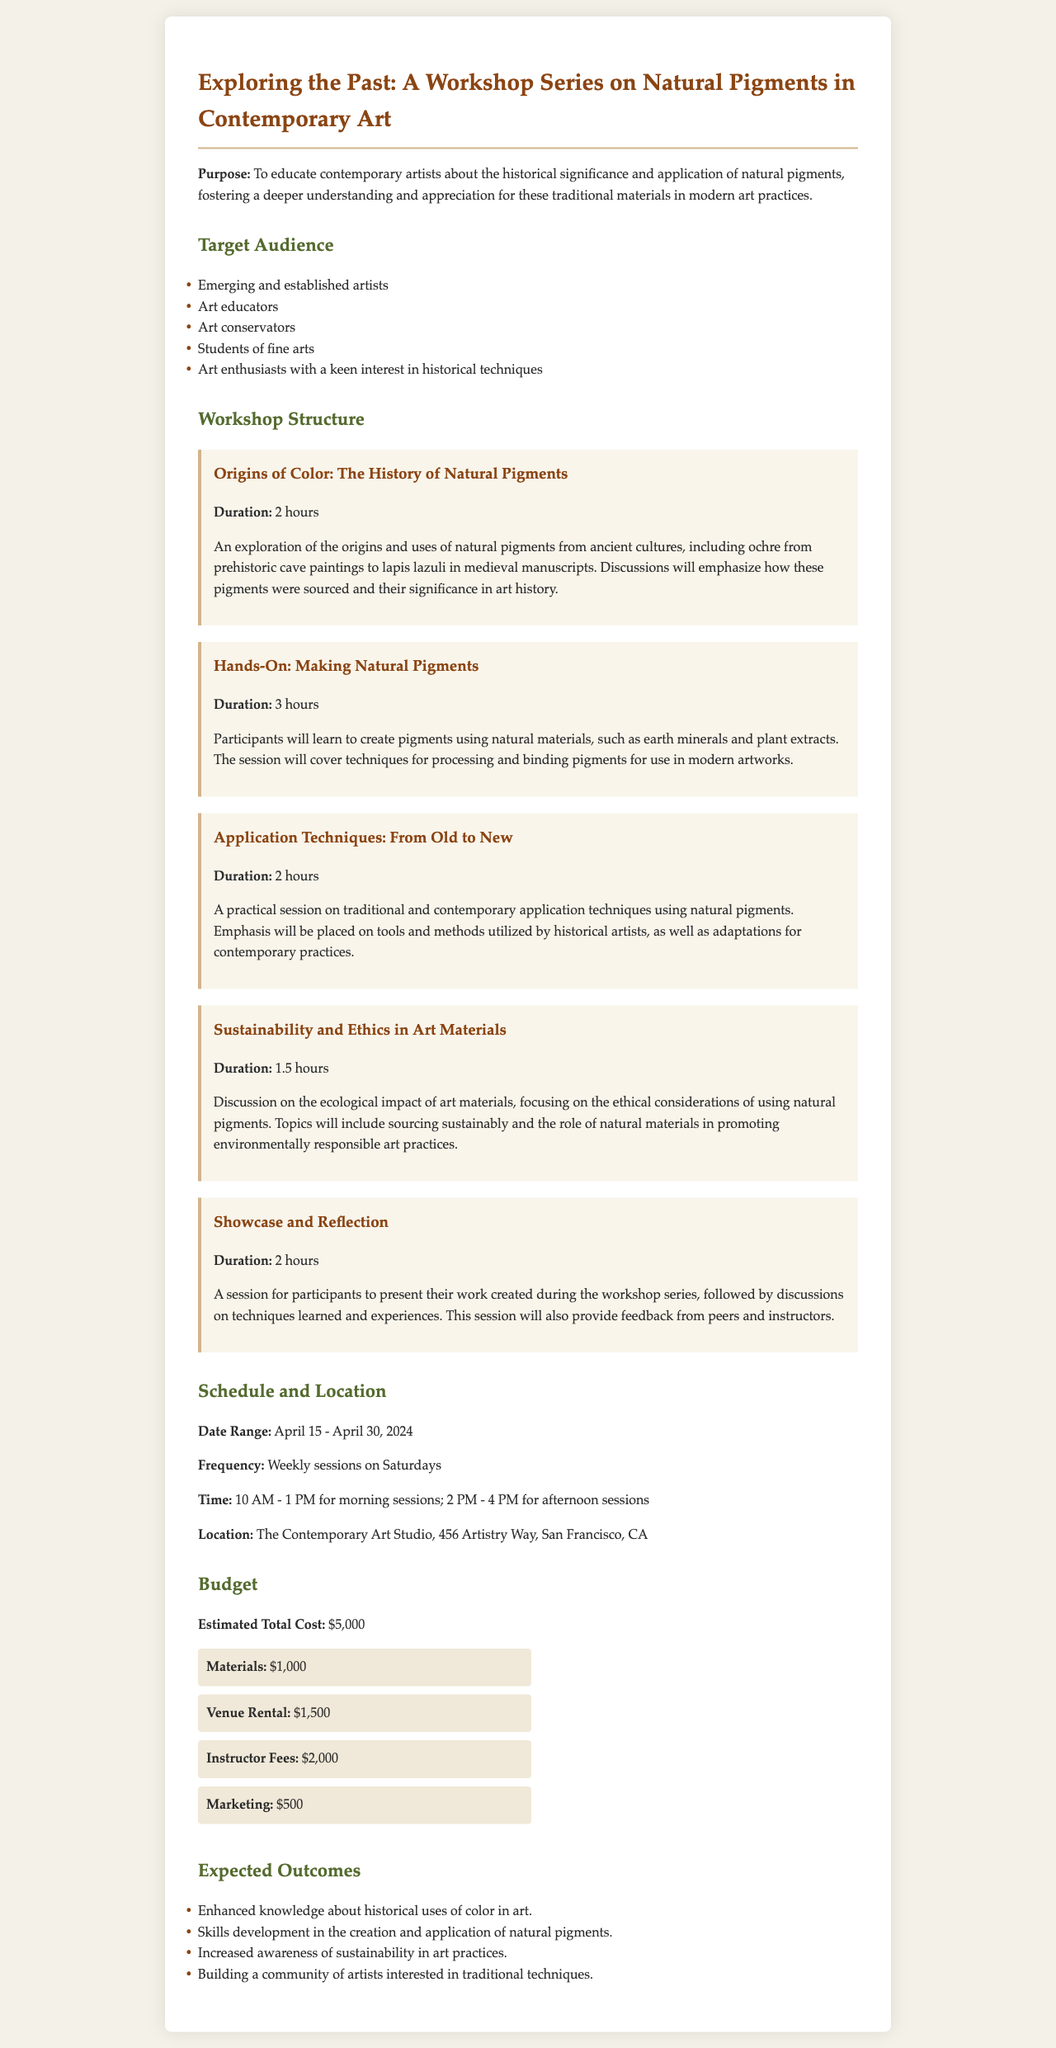What is the title of the workshop series? The title of the workshop series is stated in the document as "Exploring the Past: A Workshop Series on Natural Pigments in Contemporary Art."
Answer: Exploring the Past: A Workshop Series on Natural Pigments in Contemporary Art What is the expected total cost for the workshop series? The expected total cost for the workshop series is clearly mentioned in the document as $5,000.
Answer: $5,000 How long is the "Hands-On: Making Natural Pigments" session? The duration of the "Hands-On: Making Natural Pigments" session is specified in the document as 3 hours.
Answer: 3 hours When will the workshops take place? The date range for the workshops is mentioned to be from April 15 to April 30, 2024.
Answer: April 15 - April 30, 2024 What is the primary purpose of the workshop series? The primary purpose of the workshop series is summarized as educating contemporary artists about the historical significance and application of natural pigments.
Answer: To educate contemporary artists about the historical significance and application of natural pigments Who is the target audience for the workshops? The target audience includes emerging and established artists, art educators, art conservators, students of fine arts, and art enthusiasts with a keen interest in historical techniques.
Answer: Emerging and established artists, art educators, art conservators, students of fine arts, art enthusiasts How often will the workshops be held? The frequency of the workshops is described as weekly sessions on Saturdays.
Answer: Weekly sessions on Saturdays What location is specified for the workshops? The location for the workshops is given as The Contemporary Art Studio, 456 Artistry Way, San Francisco, CA.
Answer: The Contemporary Art Studio, 456 Artistry Way, San Francisco, CA What will participants discuss in the "Sustainability and Ethics in Art Materials" session? The session focuses on the ecological impact of art materials and the ethical considerations of using natural pigments.
Answer: The ecological impact of art materials and the ethical considerations of using natural pigments 